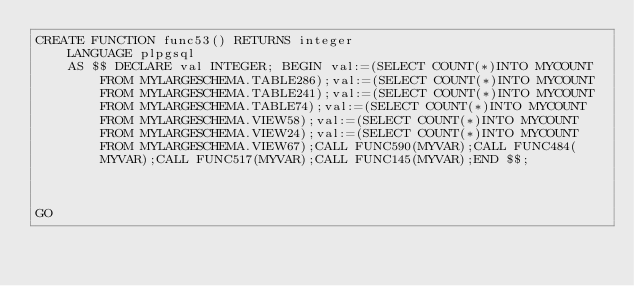<code> <loc_0><loc_0><loc_500><loc_500><_SQL_>CREATE FUNCTION func53() RETURNS integer
    LANGUAGE plpgsql
    AS $$ DECLARE val INTEGER; BEGIN val:=(SELECT COUNT(*)INTO MYCOUNT FROM MYLARGESCHEMA.TABLE286);val:=(SELECT COUNT(*)INTO MYCOUNT FROM MYLARGESCHEMA.TABLE241);val:=(SELECT COUNT(*)INTO MYCOUNT FROM MYLARGESCHEMA.TABLE74);val:=(SELECT COUNT(*)INTO MYCOUNT FROM MYLARGESCHEMA.VIEW58);val:=(SELECT COUNT(*)INTO MYCOUNT FROM MYLARGESCHEMA.VIEW24);val:=(SELECT COUNT(*)INTO MYCOUNT FROM MYLARGESCHEMA.VIEW67);CALL FUNC590(MYVAR);CALL FUNC484(MYVAR);CALL FUNC517(MYVAR);CALL FUNC145(MYVAR);END $$;



GO</code> 